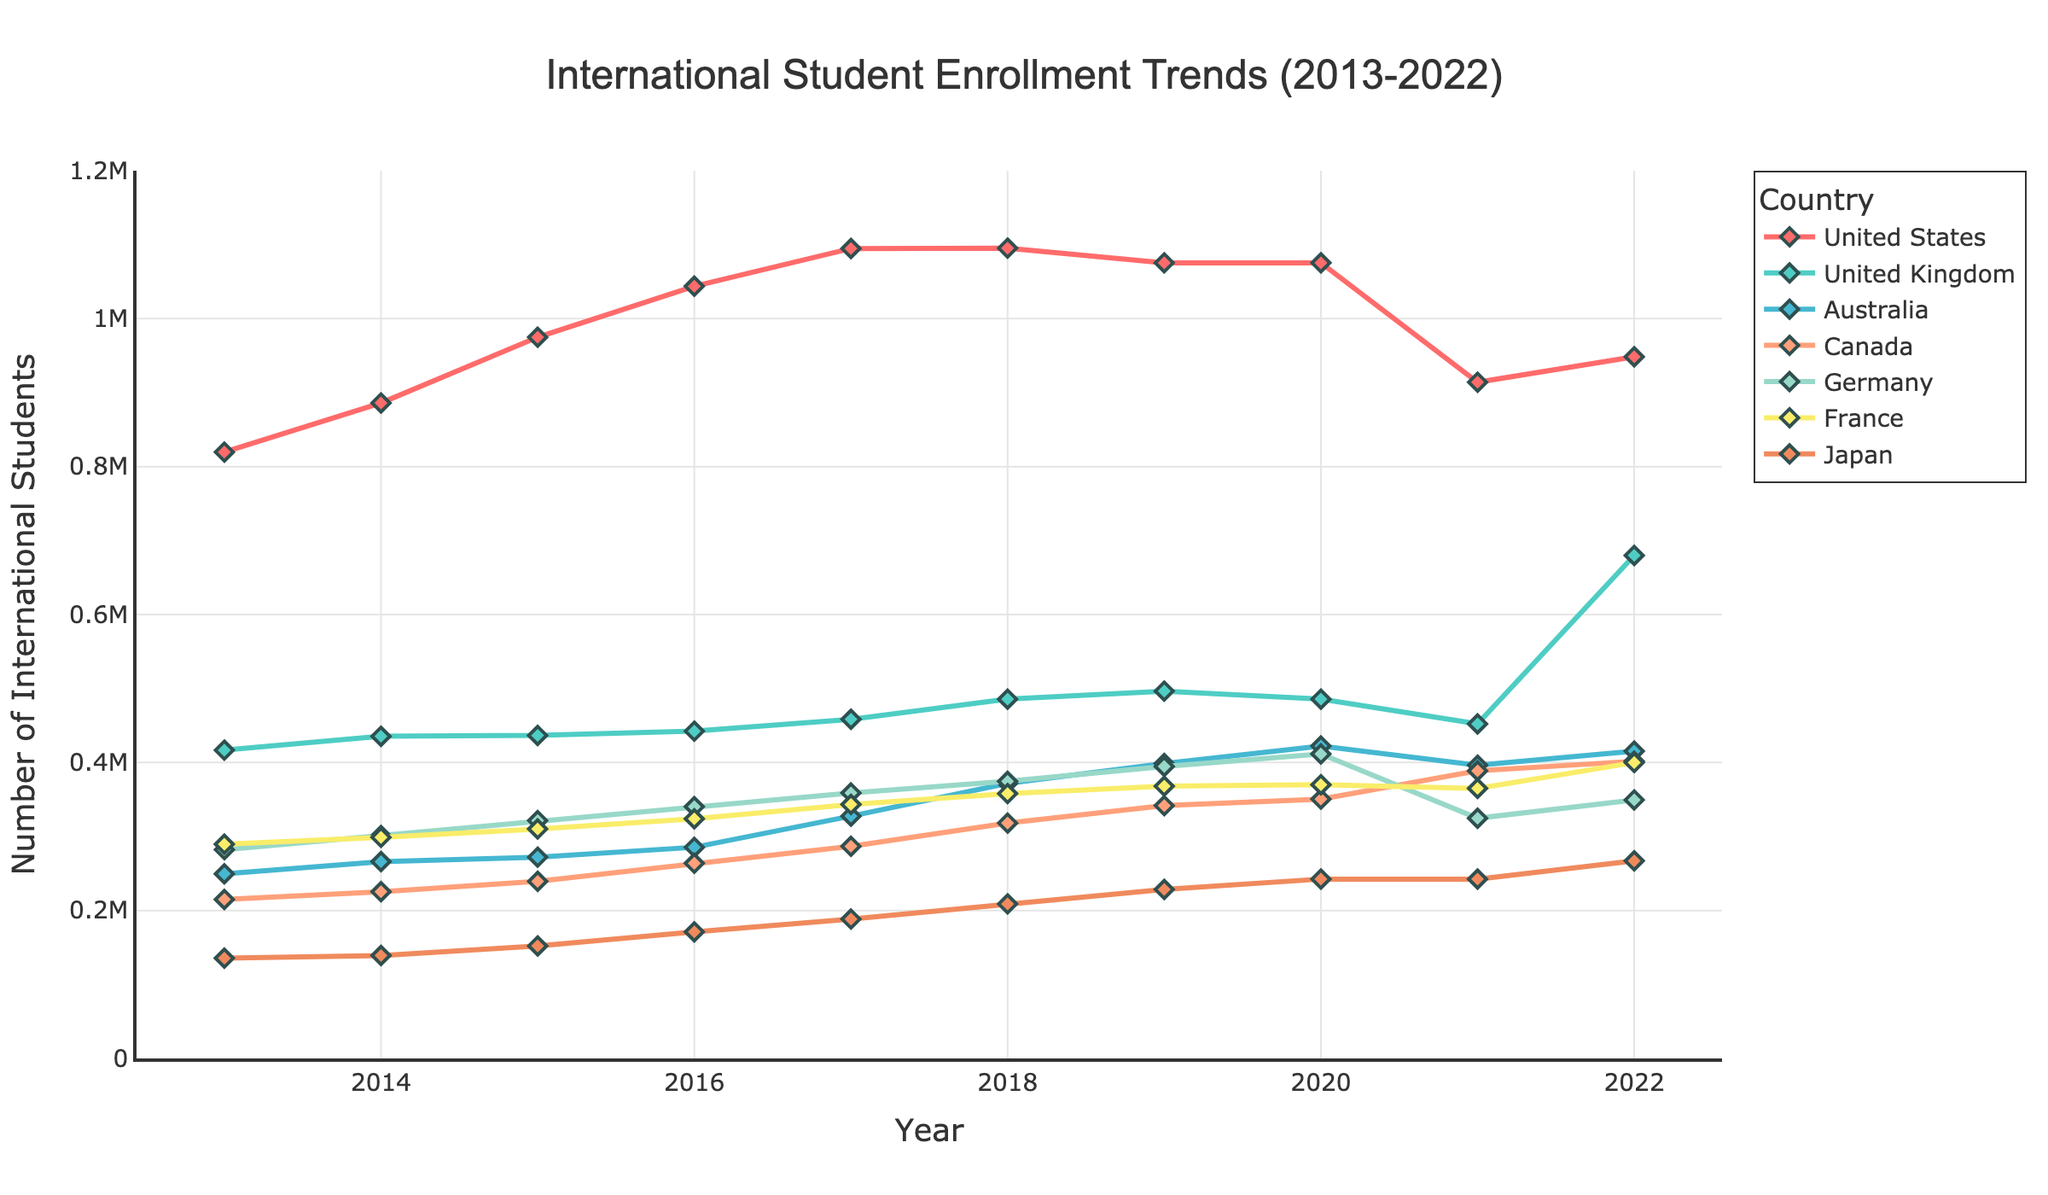what is the trend of international student enrollment in the United States from 2013 to 2022? Look at the line representing the United States. It shows a general increase from 2013 to 2019, a decline in 2021, and another increase in 2022.
Answer: Increasing, then declining, then increasing Which country had the highest number of international students enrolled in 2022? Identify the highest point on the chart for the year 2022. The United Kingdom had the highest number of students.
Answer: United Kingdom What was the difference in the number of international students between the United States and Germany in 2016? Locate the 2016 data points for the United States (1,043,839) and Germany (340,305). Subtract Germany's number from the United States' number: 1,043,839 - 340,305.
Answer: 703,534 Which country shows a continuous increase in international student enrollment from 2013 to 2017? Identify the trend lines that consistently move upward between 2013 and 2017. Australia shows a continuous increase.
Answer: Australia Did Japan see a higher enrollment than France in any year? Compare the enrollment numbers of Japan and France across all the years. Japan never surpasses France in the number of international students.
Answer: No In which year did Canada surpass 300,000 international student enrollments for the first time? Track the Canada line to find the first year it crosses the 300,000 mark. Canada surpasses 300,000 in 2018.
Answer: 2018 What’s the average number of international students in Australia from 2017 to 2019? Sum the number of students in Australia for 2017 (327,606), 2018 (371,885), and 2019 (398,563). Then divide by 3: (327,606 + 371,885 + 398,563) / 3.
Answer: 366,685 Which country had the steepest decline in international student enrollment in 2021 compared to 2020? Compare the 2020 and 2021 data points for all countries and find the largest drop. The United States had the steepest decline.
Answer: United States What’s the total number of international students in the top 3 countries in 2022? Sum the enrollment numbers of the three highest-ranking countries in 2022: United Kingdom (679,970), United States (948,519), and France (400,000).
Answer: 2,028,489 How did the number of international students in Germany change from 2019 to 2022? Look at Germany’s numbers in 2019 (394,665) and 2022 (349,438). Subtract 349,438 from 394,665. The number decreased by 394,665 - 349,438.
Answer: 45,227 decrease 